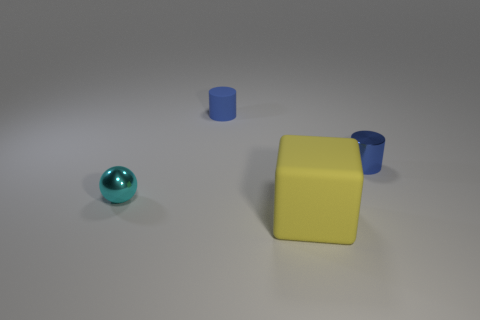Are there any other things that are the same size as the matte cube?
Give a very brief answer. No. What number of other tiny blue things have the same shape as the small rubber object?
Your answer should be compact. 1. There is a rubber object in front of the small shiny object left of the metal cylinder; what is its color?
Keep it short and to the point. Yellow. Is the number of cyan things that are right of the metal sphere the same as the number of big matte cubes?
Offer a very short reply. No. Are there any blue metallic cylinders of the same size as the yellow cube?
Keep it short and to the point. No. There is a cyan sphere; is its size the same as the rubber thing in front of the small matte object?
Provide a short and direct response. No. Is the number of cyan things to the left of the cyan thing the same as the number of tiny cyan objects that are behind the blue shiny cylinder?
Offer a terse response. Yes. There is a tiny thing that is the same color as the small metal cylinder; what is its shape?
Your response must be concise. Cylinder. There is a blue cylinder in front of the rubber cylinder; what is its material?
Your response must be concise. Metal. Is the size of the cyan shiny object the same as the yellow object?
Your answer should be very brief. No. 